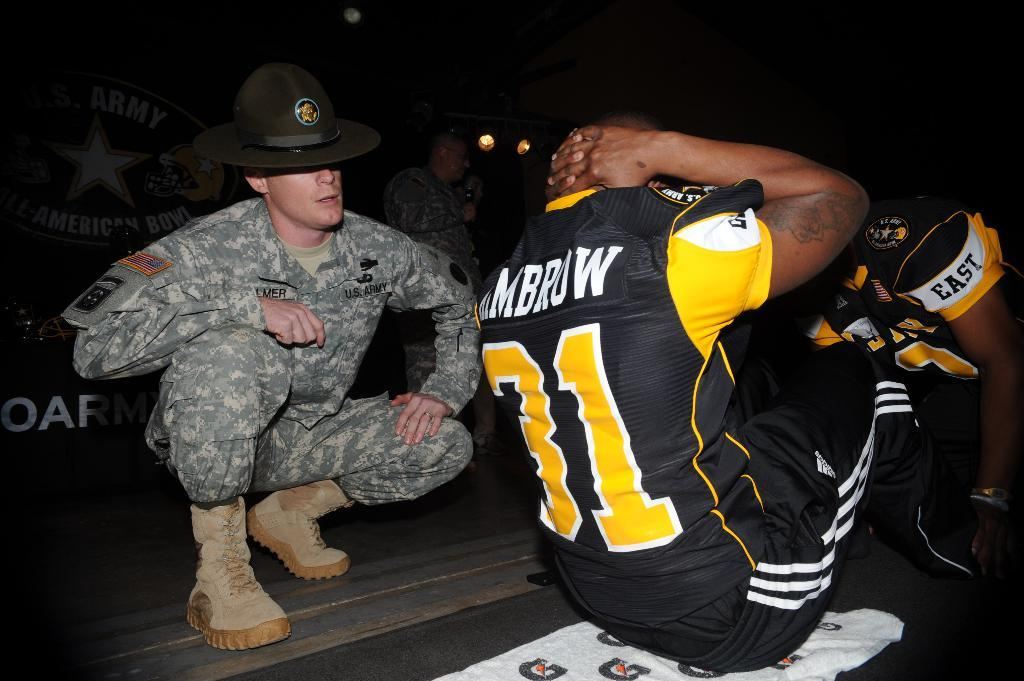<image>
Give a short and clear explanation of the subsequent image. a man that is wearing the number 31 in yellow 